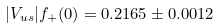<formula> <loc_0><loc_0><loc_500><loc_500>| V _ { u s } | f _ { + } ( 0 ) = 0 . 2 1 6 5 \pm 0 . 0 0 1 2</formula> 